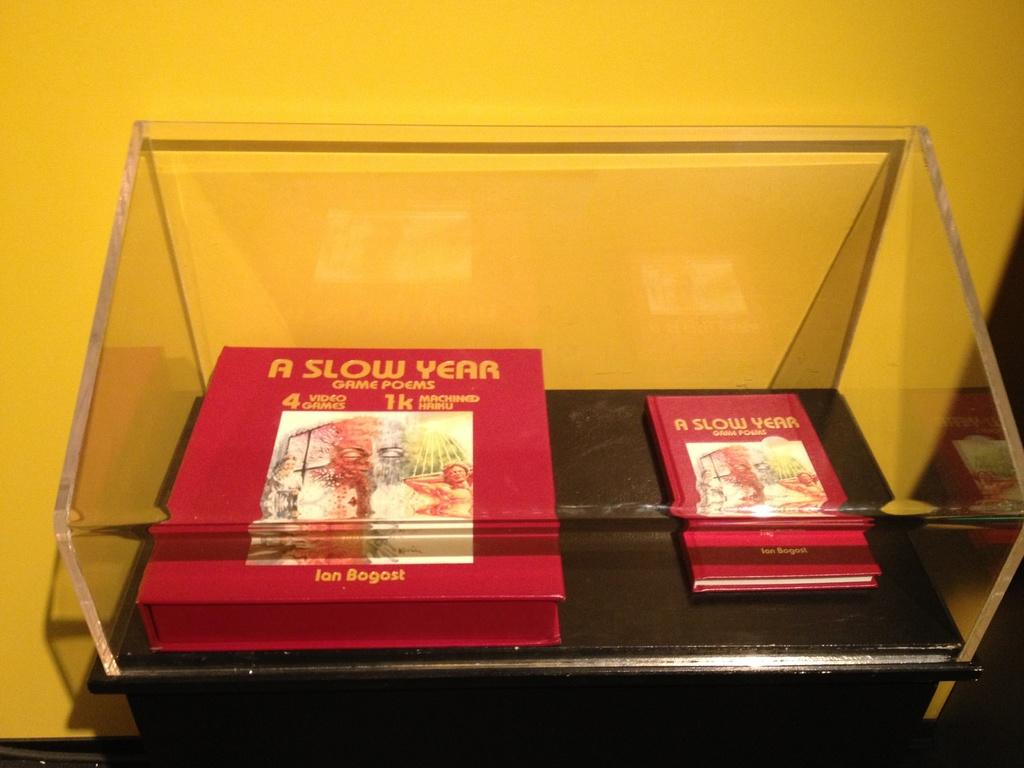<image>
Provide a brief description of the given image. Two books about a slow year in a clear case 